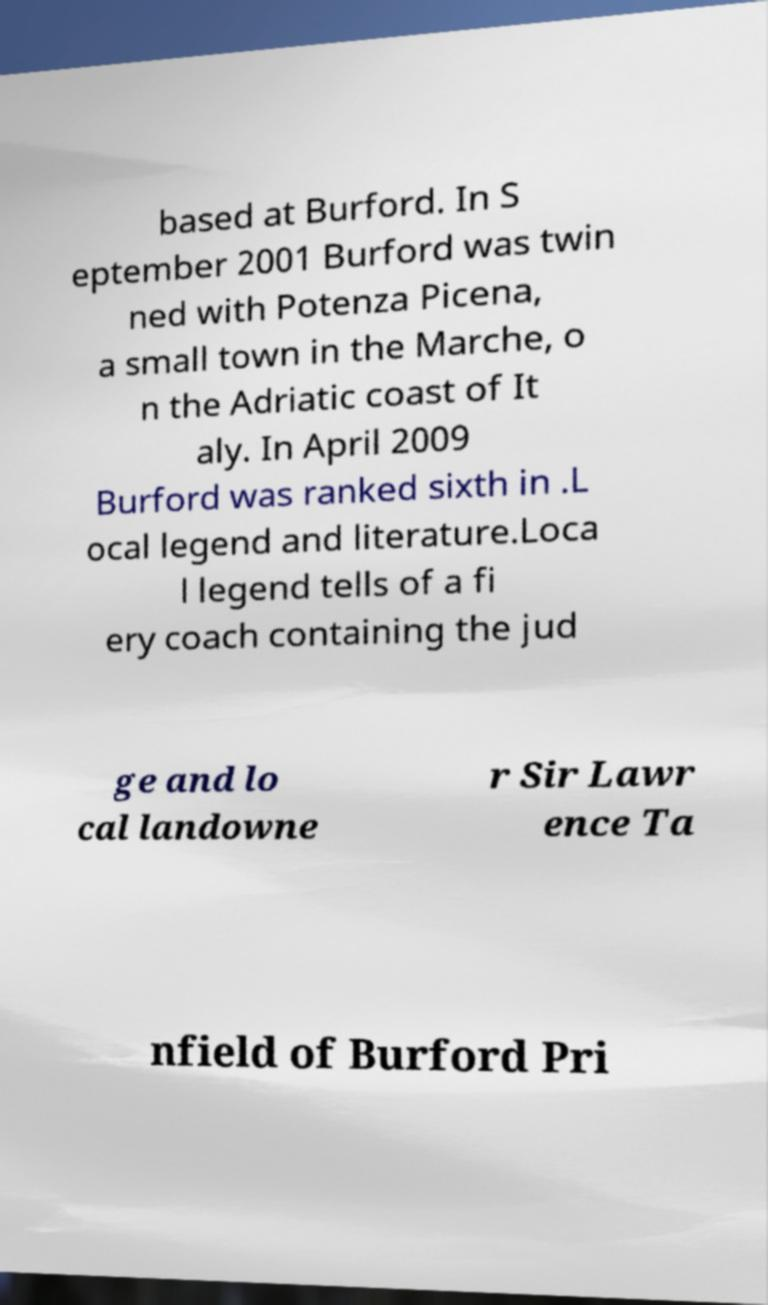For documentation purposes, I need the text within this image transcribed. Could you provide that? based at Burford. In S eptember 2001 Burford was twin ned with Potenza Picena, a small town in the Marche, o n the Adriatic coast of It aly. In April 2009 Burford was ranked sixth in .L ocal legend and literature.Loca l legend tells of a fi ery coach containing the jud ge and lo cal landowne r Sir Lawr ence Ta nfield of Burford Pri 